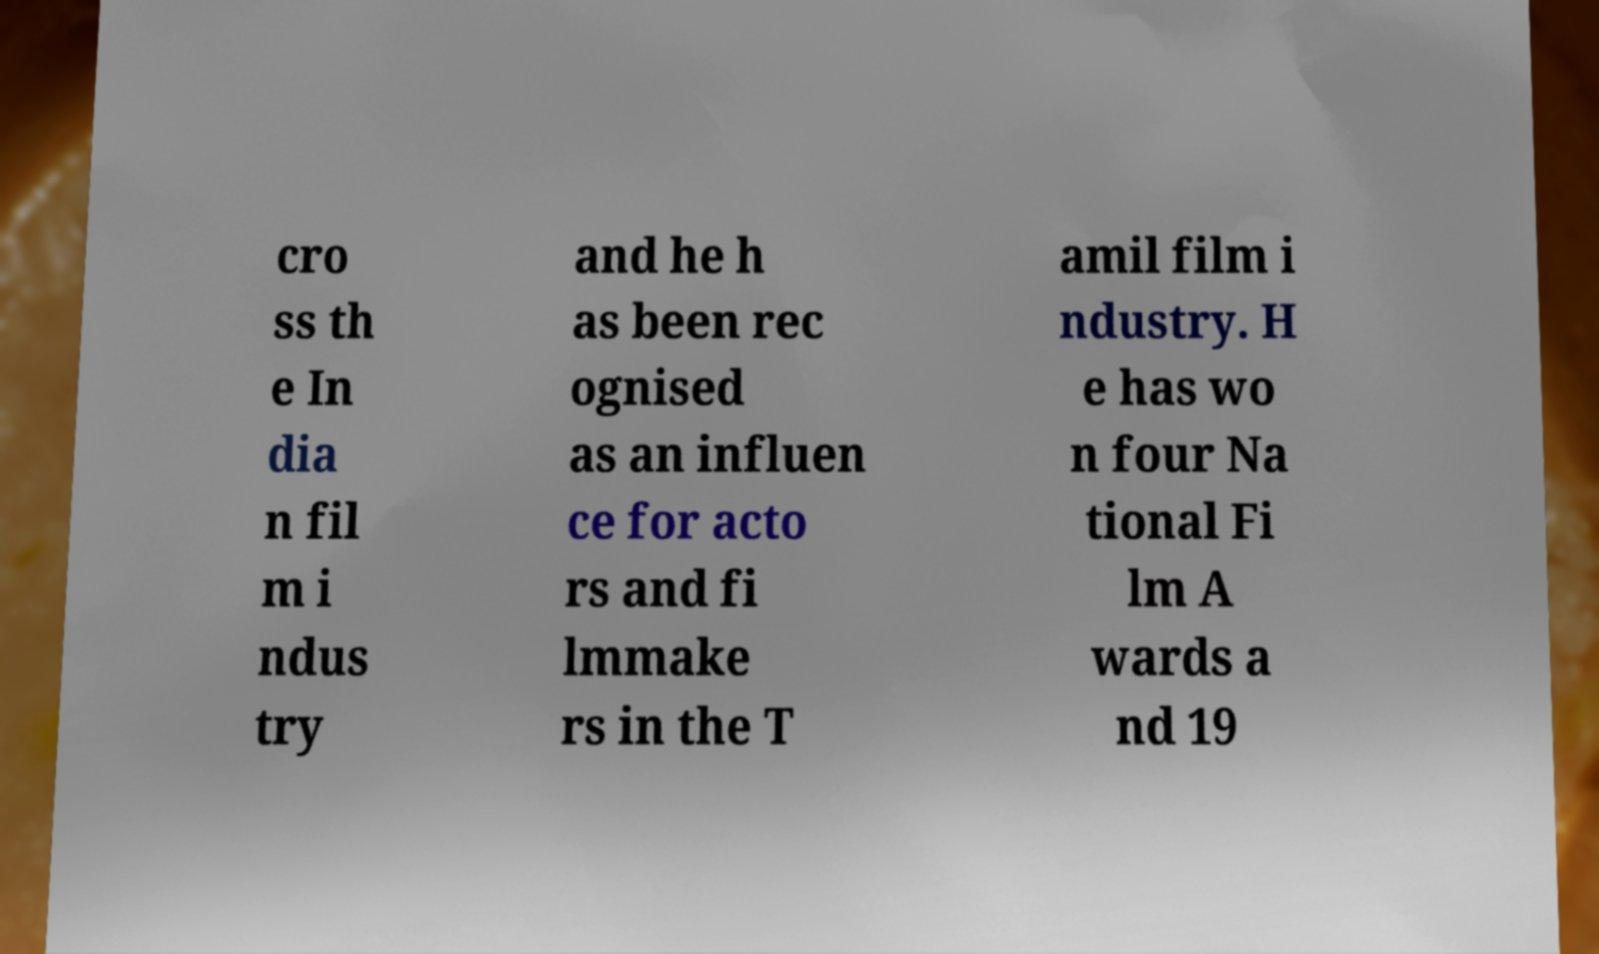Can you read and provide the text displayed in the image?This photo seems to have some interesting text. Can you extract and type it out for me? cro ss th e In dia n fil m i ndus try and he h as been rec ognised as an influen ce for acto rs and fi lmmake rs in the T amil film i ndustry. H e has wo n four Na tional Fi lm A wards a nd 19 